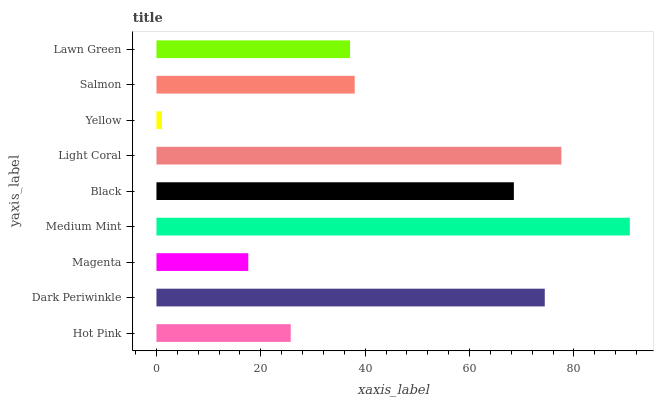Is Yellow the minimum?
Answer yes or no. Yes. Is Medium Mint the maximum?
Answer yes or no. Yes. Is Dark Periwinkle the minimum?
Answer yes or no. No. Is Dark Periwinkle the maximum?
Answer yes or no. No. Is Dark Periwinkle greater than Hot Pink?
Answer yes or no. Yes. Is Hot Pink less than Dark Periwinkle?
Answer yes or no. Yes. Is Hot Pink greater than Dark Periwinkle?
Answer yes or no. No. Is Dark Periwinkle less than Hot Pink?
Answer yes or no. No. Is Salmon the high median?
Answer yes or no. Yes. Is Salmon the low median?
Answer yes or no. Yes. Is Light Coral the high median?
Answer yes or no. No. Is Lawn Green the low median?
Answer yes or no. No. 